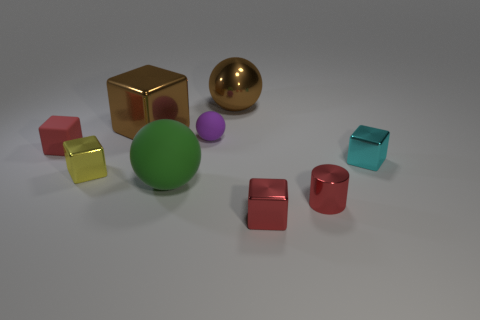What shape is the yellow metallic object? cube 